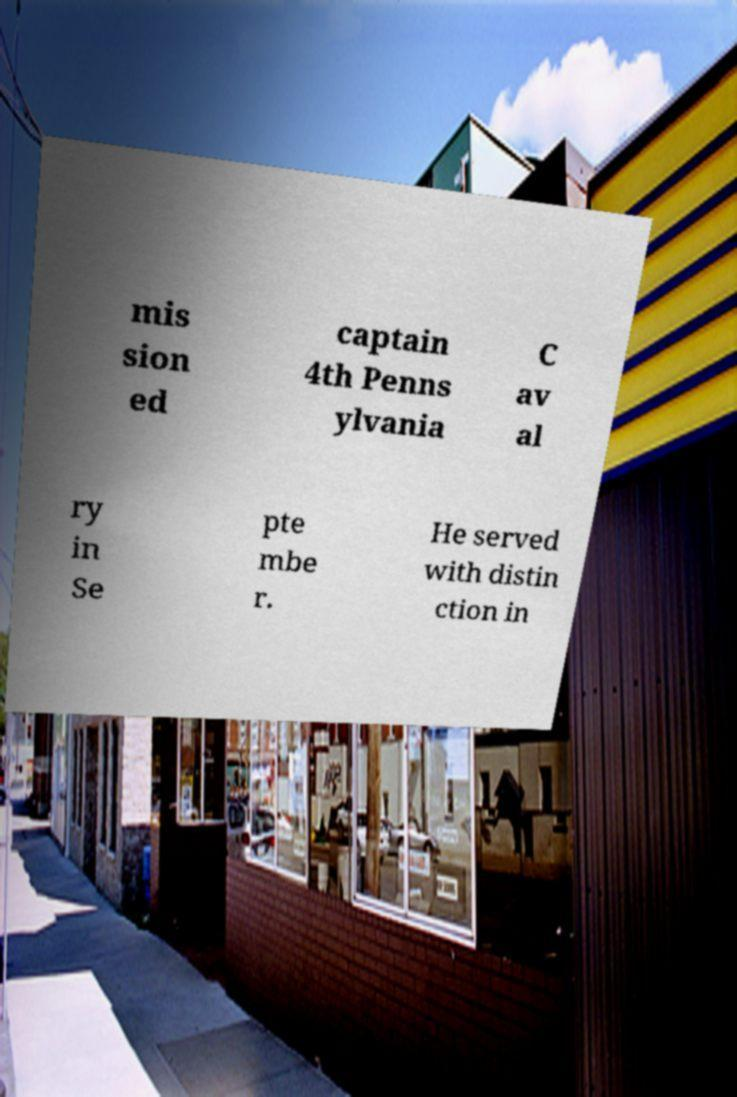There's text embedded in this image that I need extracted. Can you transcribe it verbatim? mis sion ed captain 4th Penns ylvania C av al ry in Se pte mbe r. He served with distin ction in 